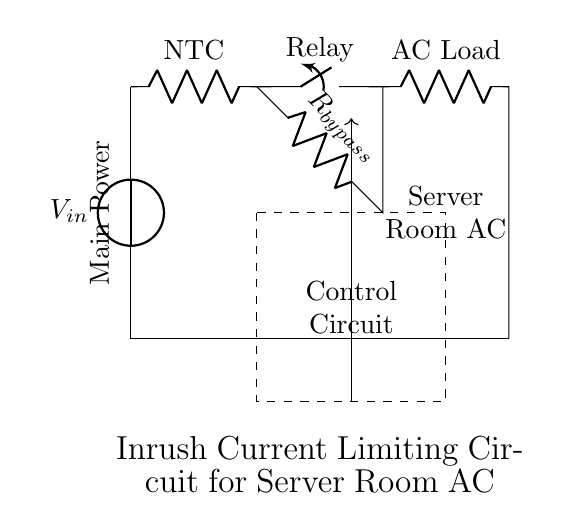What is the type of the load in this circuit? The load is defined as the component connected to the output of the circuit. In this diagram, it is labeled as "AC Load," indicating it is an air conditioning unit, which operates on alternating current.
Answer: AC Load What component limits inrush current? The circuit uses an "NTC" (Negative Temperature Coefficient) thermistor, which decreases its resistance as it heats up. Initially, it limits the inrush current when the air conditioning system starts, helping to protect circuit components.
Answer: NTC What does the relay in this circuit do? The relay functions as a switch that controls the connection to the AC load. When activated, it closes the circuit allowing full current flow to the load while initially limiting it during startup, this helps manage inrush current.
Answer: Closing switch What is the purpose of the bypass resistor in this design? The bypass resistor provides an alternative path for current that bypasses the NTC after it has warmed up and reduced resistance. This allows continuous power to the AC unit without the current limiting effect once the system is stable, enhancing efficiency.
Answer: Continuous power Describe the control mechanism for the relay. The control mechanism is illustrated as a dashed rectangle labeled "Control Circuit." This indicates that there is an external control mechanism that will regulate the relay operation based on different conditions, ensuring proper management of the inrush current and system protection.
Answer: Control Circuit How does the NTC thermistor respond to changes in temperature? The NTC thermistor decreases its resistance as its temperature rises due to the current passing through it. This characteristic helps to limit the initial surge of current when the air conditioning unit is turned on, gradually allowing more current as the thermistor heats.
Answer: Decrease resistance What is the main power source voltage in this circuit? The main power supply is indicated in the circuit as "V_in," but the exact voltage value is not specified in the provided circuit diagram. It typically would depend on the specific application and the required power for the air conditioning system.
Answer: V_in 